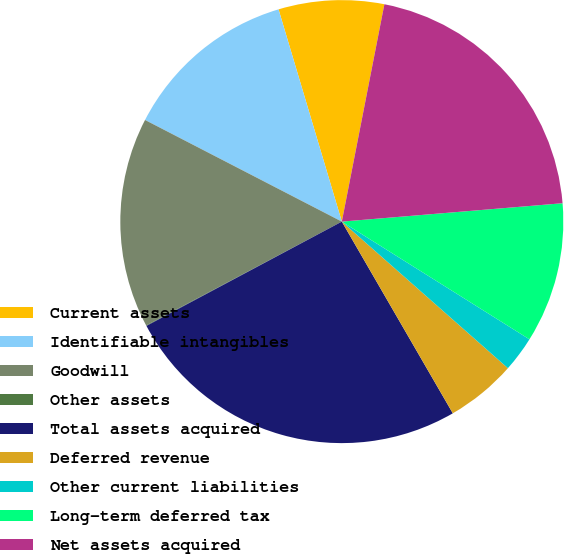Convert chart. <chart><loc_0><loc_0><loc_500><loc_500><pie_chart><fcel>Current assets<fcel>Identifiable intangibles<fcel>Goodwill<fcel>Other assets<fcel>Total assets acquired<fcel>Deferred revenue<fcel>Other current liabilities<fcel>Long-term deferred tax<fcel>Net assets acquired<nl><fcel>7.69%<fcel>12.8%<fcel>15.35%<fcel>0.04%<fcel>25.55%<fcel>5.14%<fcel>2.59%<fcel>10.24%<fcel>20.6%<nl></chart> 